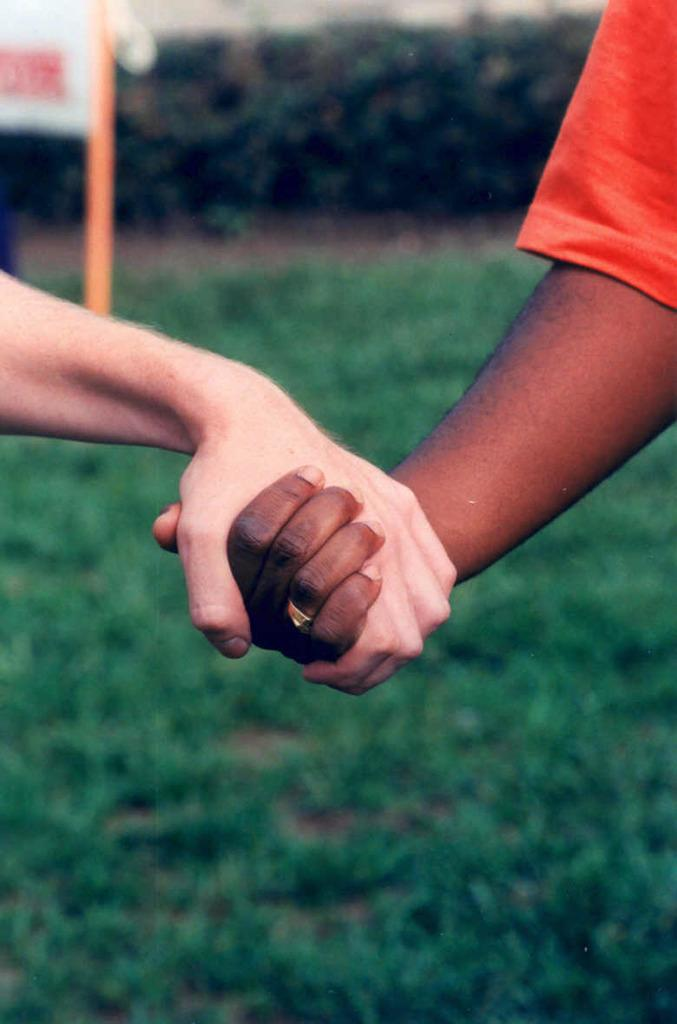How many people are in the image? There are two people in the image. What are the two people doing in the image? The two people are holding hands. What type of ground is visible at the bottom of the image? There is grass at the bottom of the image. What can be seen in the background of the image? There is a board and a hedge visible in the background of the image. What type of pest can be seen crawling on the board in the background of the image? There is no pest visible on the board in the background of the image. How does the toad control the hedge in the image? There is no toad present in the image, and therefore no control over the hedge can be observed. 